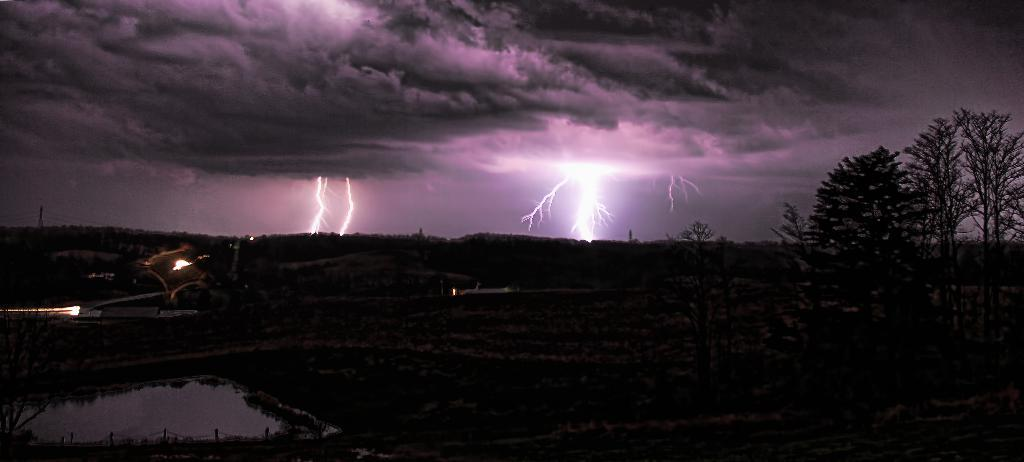What is the overall lighting condition in the image? The image is dark. What type of vegetation can be seen in the image? There are trees visible in the image. What natural element is also visible in the image? There is water visible in the image. What is visible at the top of the image? The sky is visible at the top of the image. Can you tell me how many zebras are swimming in the water in the image? There are no zebras present in the image; it features trees, water, and a dark sky. What type of hair is visible on the trees in the image? Trees do not have hair; they have leaves and branches. 